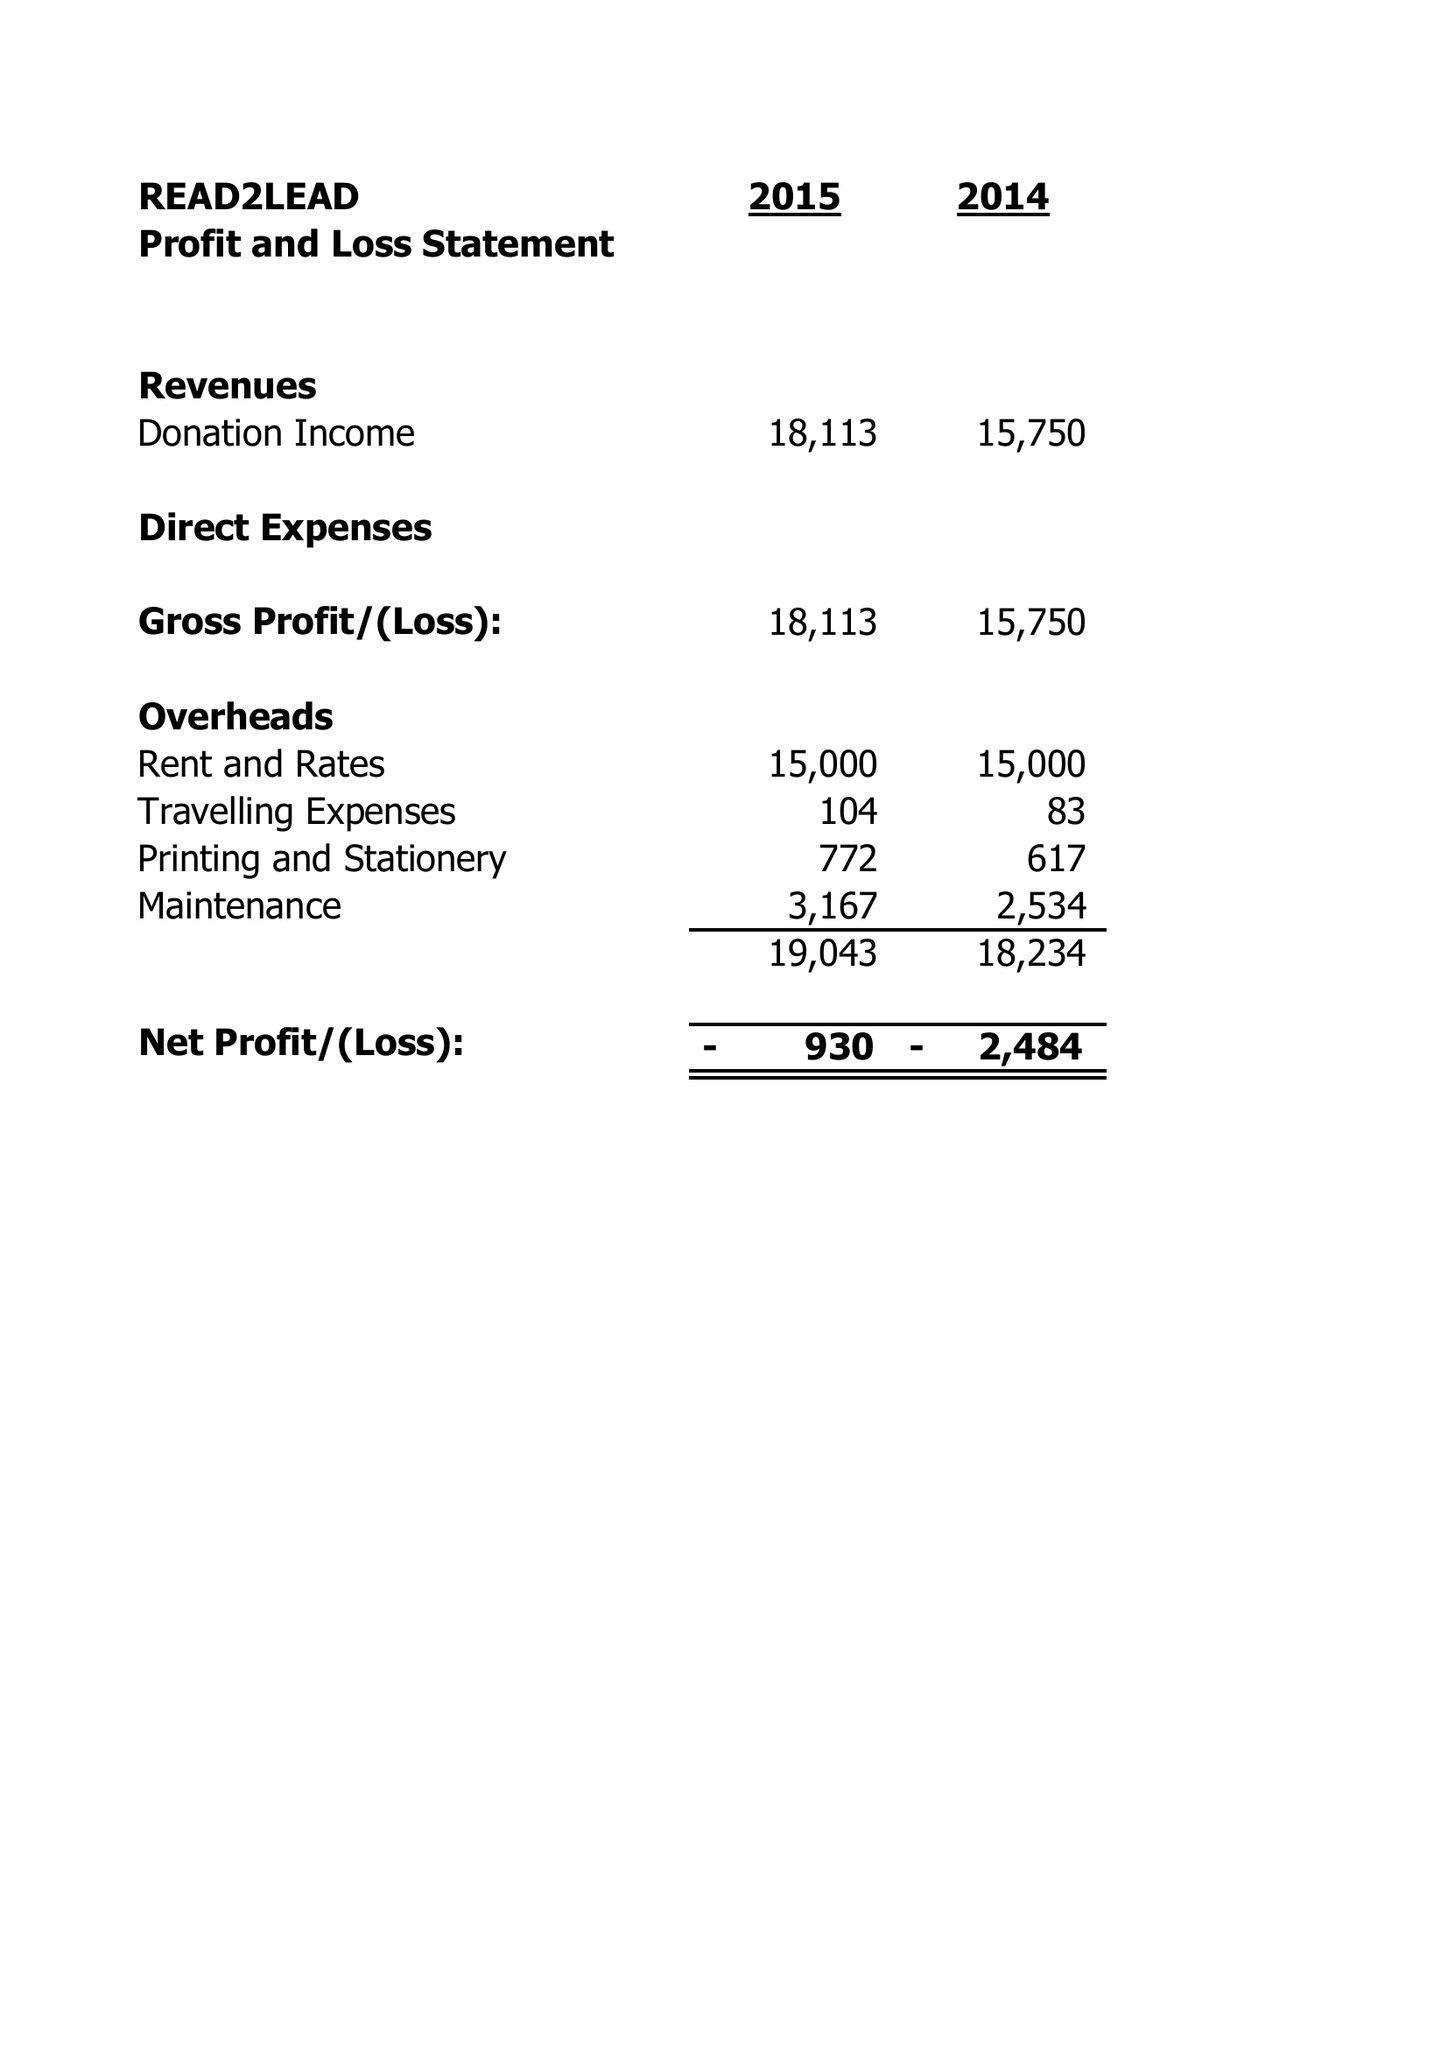What is the value for the income_annually_in_british_pounds?
Answer the question using a single word or phrase. 24900.00 